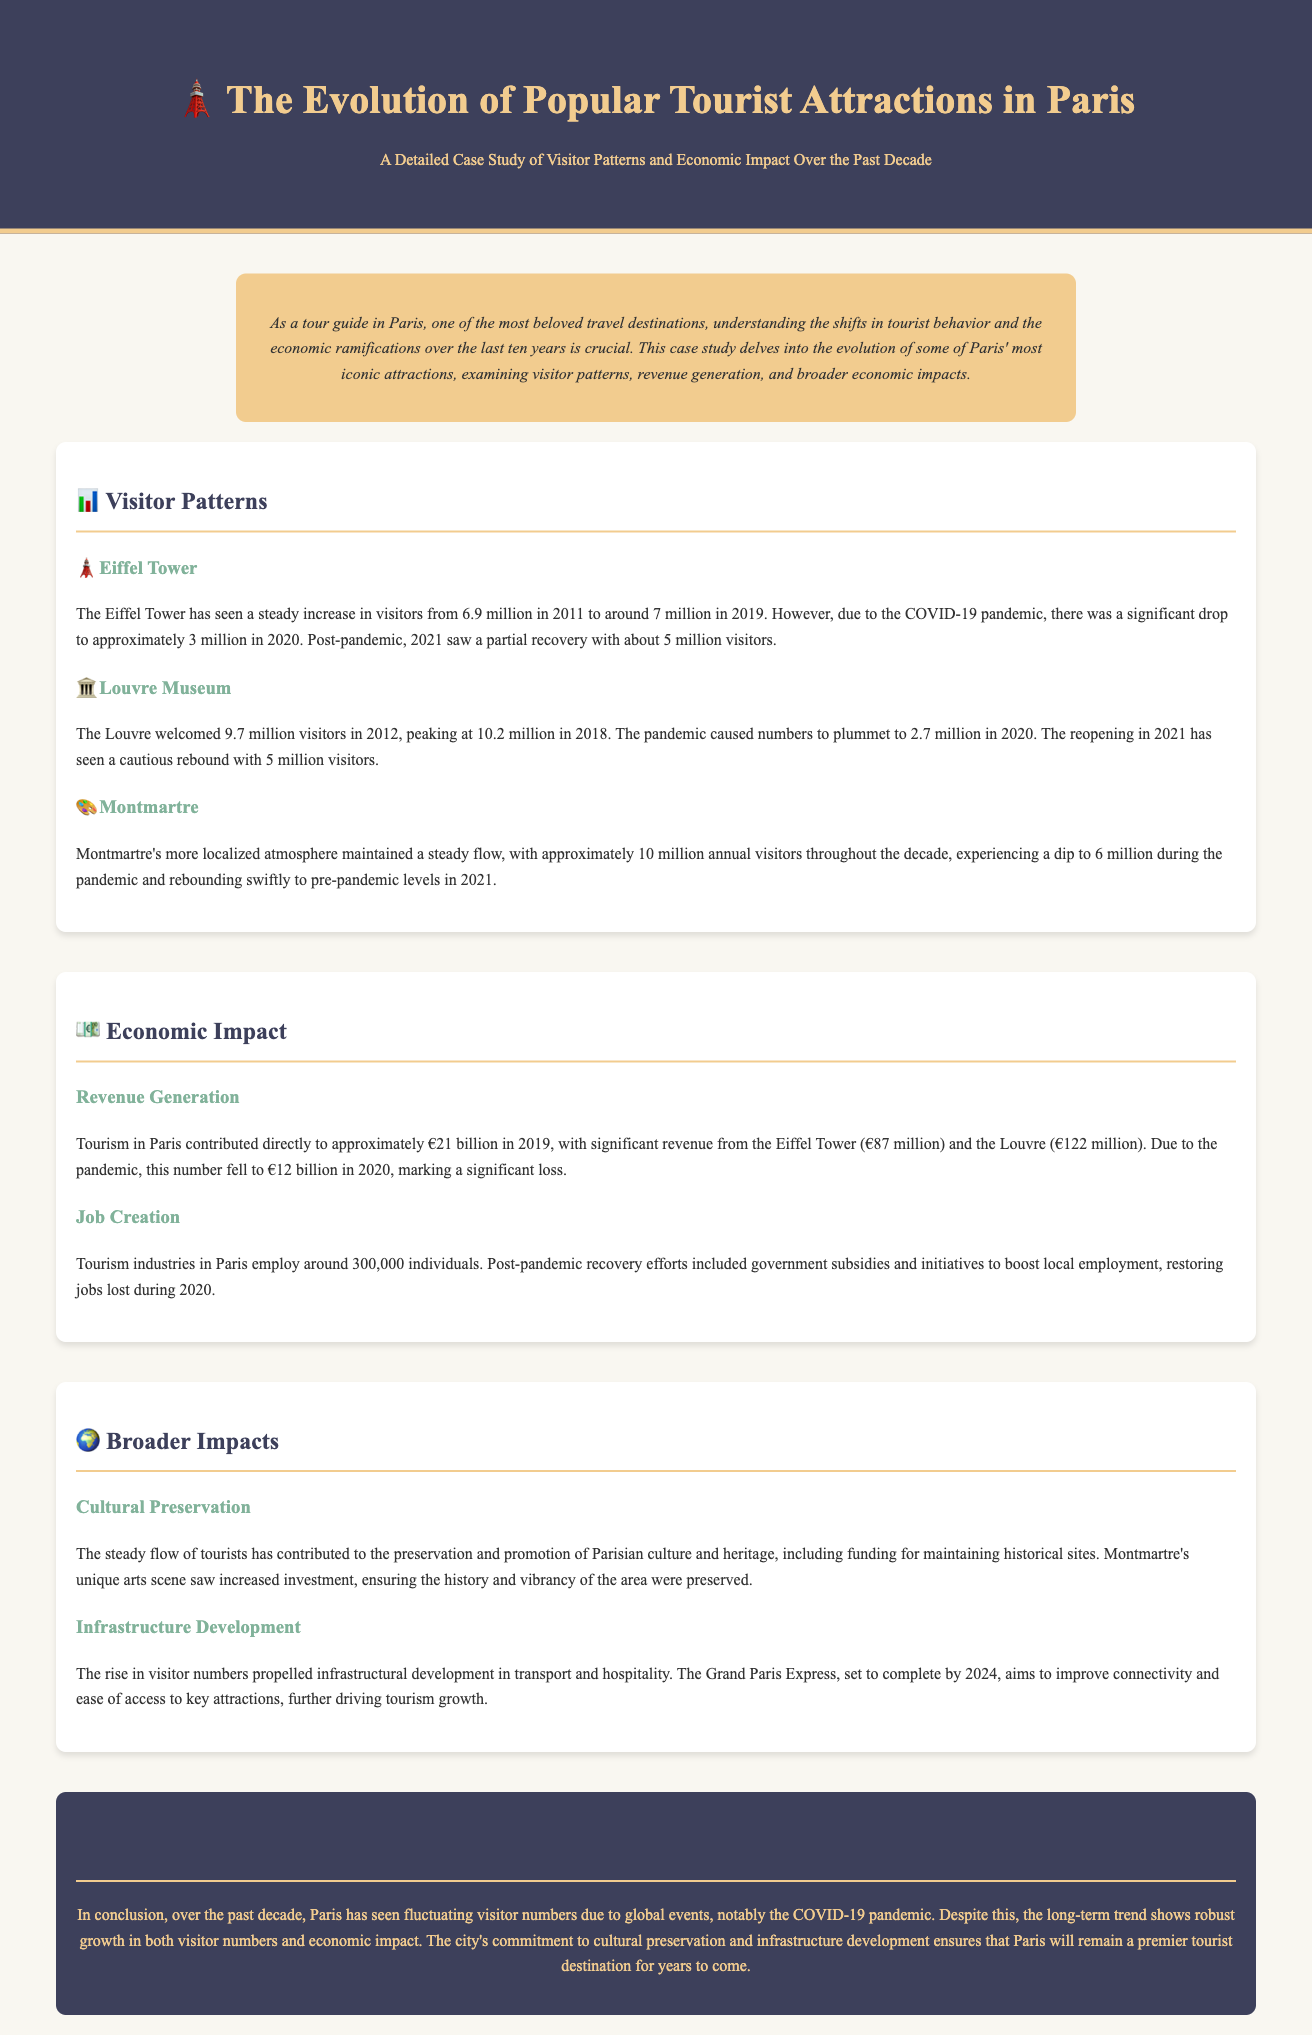What was the number of visitors to the Eiffel Tower in 2019? The number of visitors to the Eiffel Tower in 2019 was reported to be around 7 million.
Answer: 7 million What was the visitor count for the Louvre in 2020? The visitor count for the Louvre in 2020 dropped to approximately 2.7 million due to the pandemic.
Answer: 2.7 million How much did tourism in Paris contribute directly to the economy in 2019? The direct contribution of tourism to the Paris economy in 2019 was approximately €21 billion.
Answer: €21 billion What was the lowest visitor number for Montmartre during the pandemic? Montmartre experienced a low of 6 million visitors during the pandemic in 2020.
Answer: 6 million What was the revenue generated by the Eiffel Tower in 2019? The revenue generated by the Eiffel Tower in 2019 was €87 million.
Answer: €87 million How many individuals are employed in the tourism industry in Paris? The tourism industry in Paris employs around 300,000 individuals.
Answer: 300,000 What significant infrastructure project is set to complete by 2024? The Grand Paris Express is the key infrastructure project set to complete by 2024.
Answer: Grand Paris Express What aspect of culture does tourism in Paris help to preserve? Tourism in Paris contributes to the preservation of Parisian culture and heritage.
Answer: Parisian culture and heritage What year did the Louvre peak in visitor numbers? The Louvre peaked in visitor numbers in 2018 with 10.2 million visitors.
Answer: 2018 